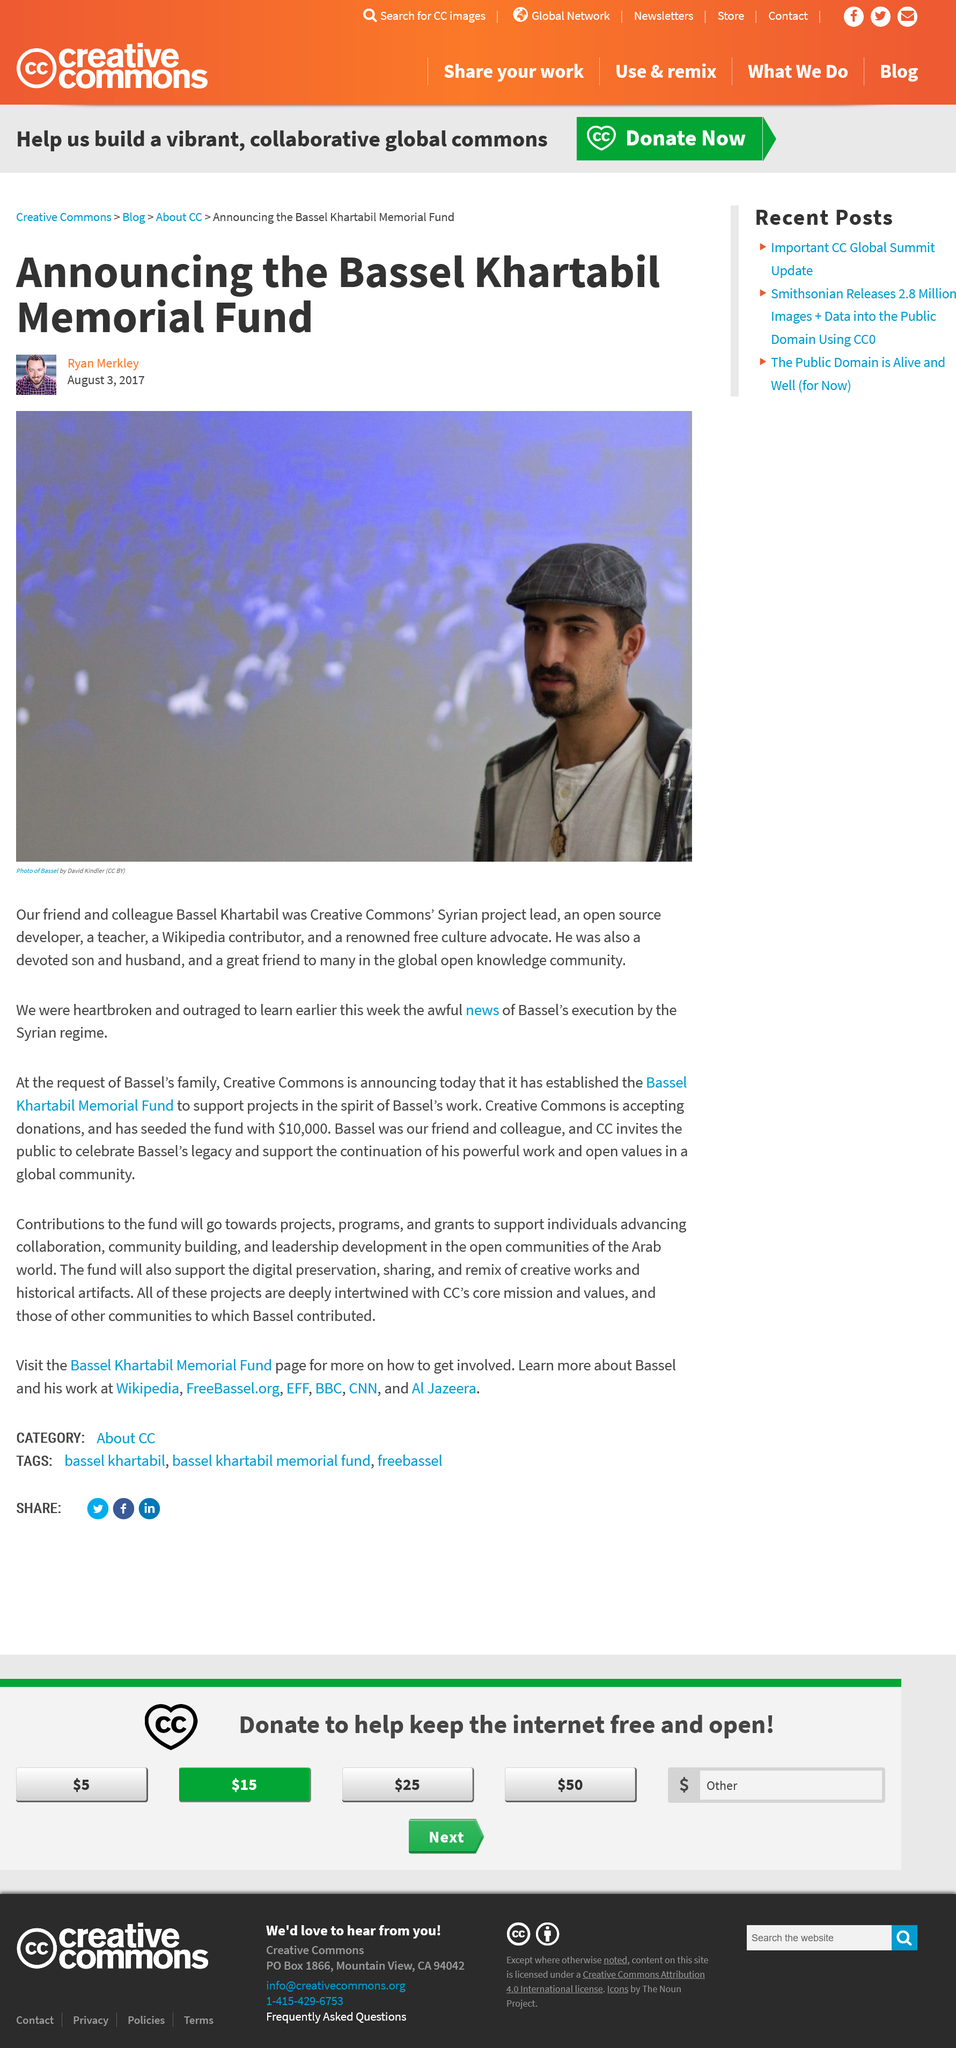Draw attention to some important aspects in this diagram. The Creative Commons' Syrian project leader died as a result of execution by the Syrian regime. Bassel Khartabil was the Syrian project lead for Creative Commons. Khartabil Both was an open source developer and a teacher. 